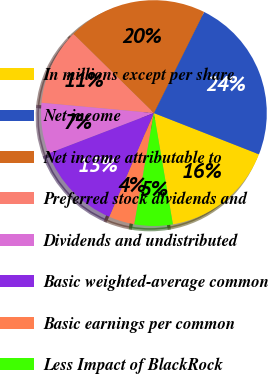Convert chart to OTSL. <chart><loc_0><loc_0><loc_500><loc_500><pie_chart><fcel>In millions except per share<fcel>Net income<fcel>Net income attributable to<fcel>Preferred stock dividends and<fcel>Dividends and undistributed<fcel>Basic weighted-average common<fcel>Basic earnings per common<fcel>Less Impact of BlackRock<nl><fcel>16.36%<fcel>23.61%<fcel>19.98%<fcel>10.91%<fcel>7.28%<fcel>12.73%<fcel>3.66%<fcel>5.47%<nl></chart> 